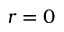<formula> <loc_0><loc_0><loc_500><loc_500>r = 0</formula> 